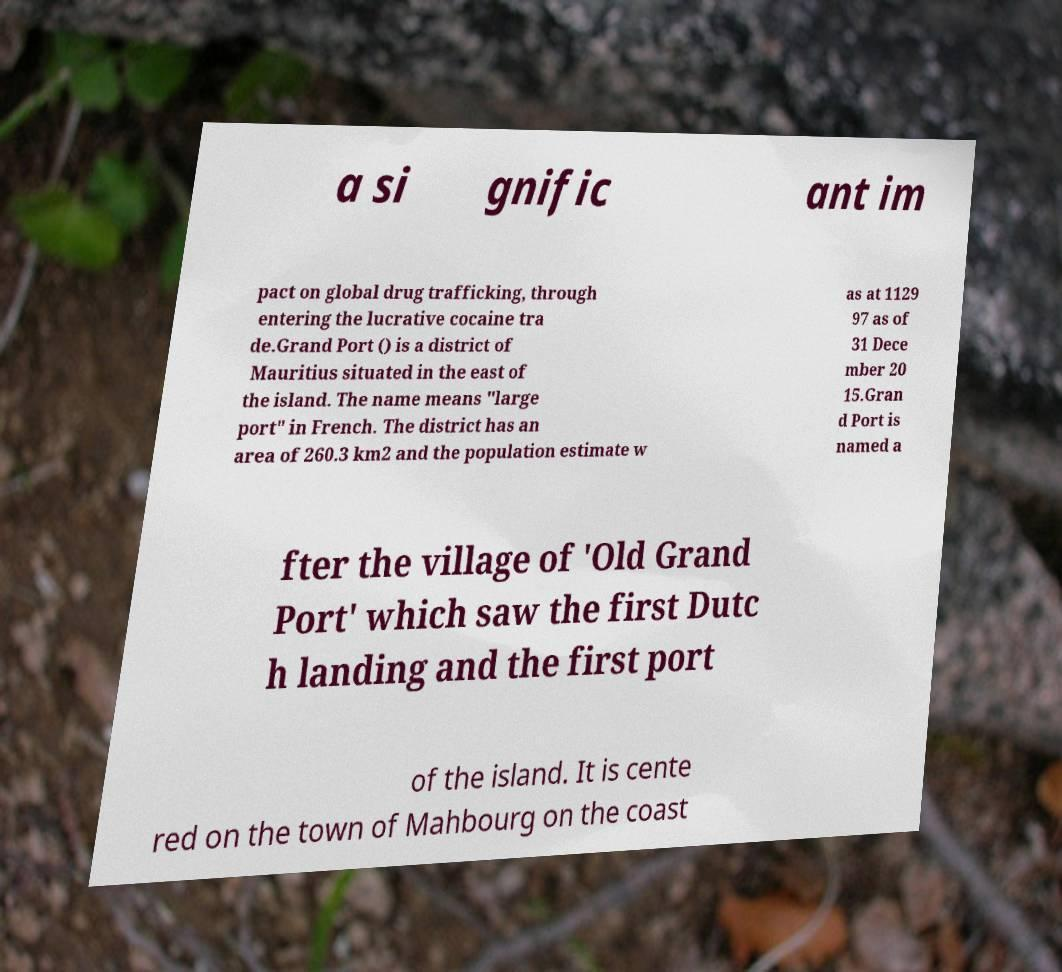For documentation purposes, I need the text within this image transcribed. Could you provide that? a si gnific ant im pact on global drug trafficking, through entering the lucrative cocaine tra de.Grand Port () is a district of Mauritius situated in the east of the island. The name means "large port" in French. The district has an area of 260.3 km2 and the population estimate w as at 1129 97 as of 31 Dece mber 20 15.Gran d Port is named a fter the village of 'Old Grand Port' which saw the first Dutc h landing and the first port of the island. It is cente red on the town of Mahbourg on the coast 